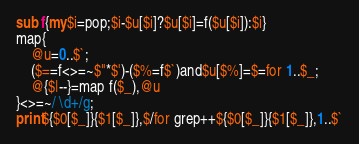Convert code to text. <code><loc_0><loc_0><loc_500><loc_500><_Perl_>sub f{my$i=pop;$i-$u[$i]?$u[$i]=f($u[$i]):$i}
map{
	@u=0..$`;
	($==f<>=~$"*$')-($%=f$`)and$u[$%]=$=for 1..$_;
	@{$|--}=map f($_),@u
}<>=~/ \d+/g;
print${$0[$_]}{$1[$_]},$/for grep++${$0[$_]}{$1[$_]},1..$`
</code> 